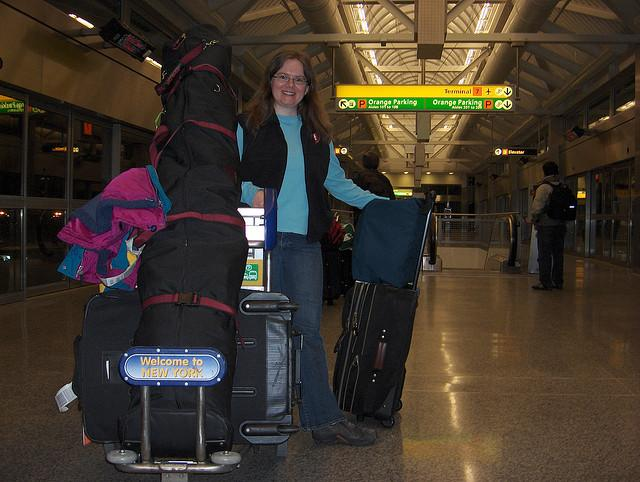What color are the straps wrapping up the black duffel on the luggage rack? Please explain your reasoning. purple. It's the only closest option since they're more of a red or burgandy. 